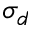Convert formula to latex. <formula><loc_0><loc_0><loc_500><loc_500>\sigma _ { d }</formula> 